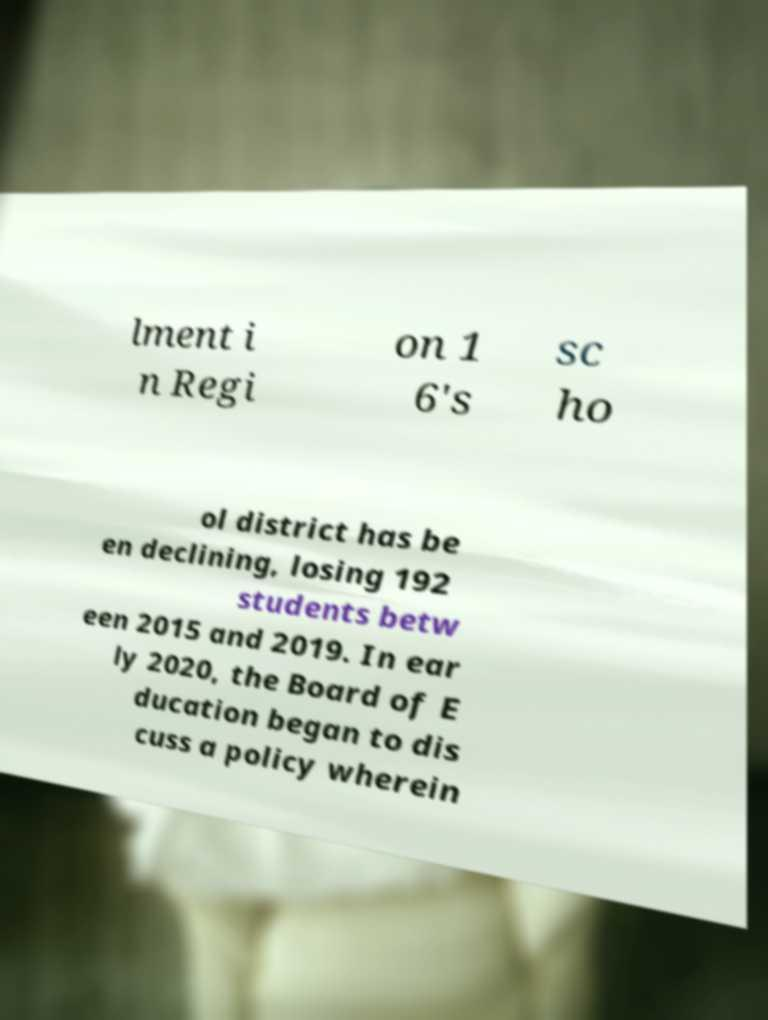Could you extract and type out the text from this image? lment i n Regi on 1 6's sc ho ol district has be en declining, losing 192 students betw een 2015 and 2019. In ear ly 2020, the Board of E ducation began to dis cuss a policy wherein 